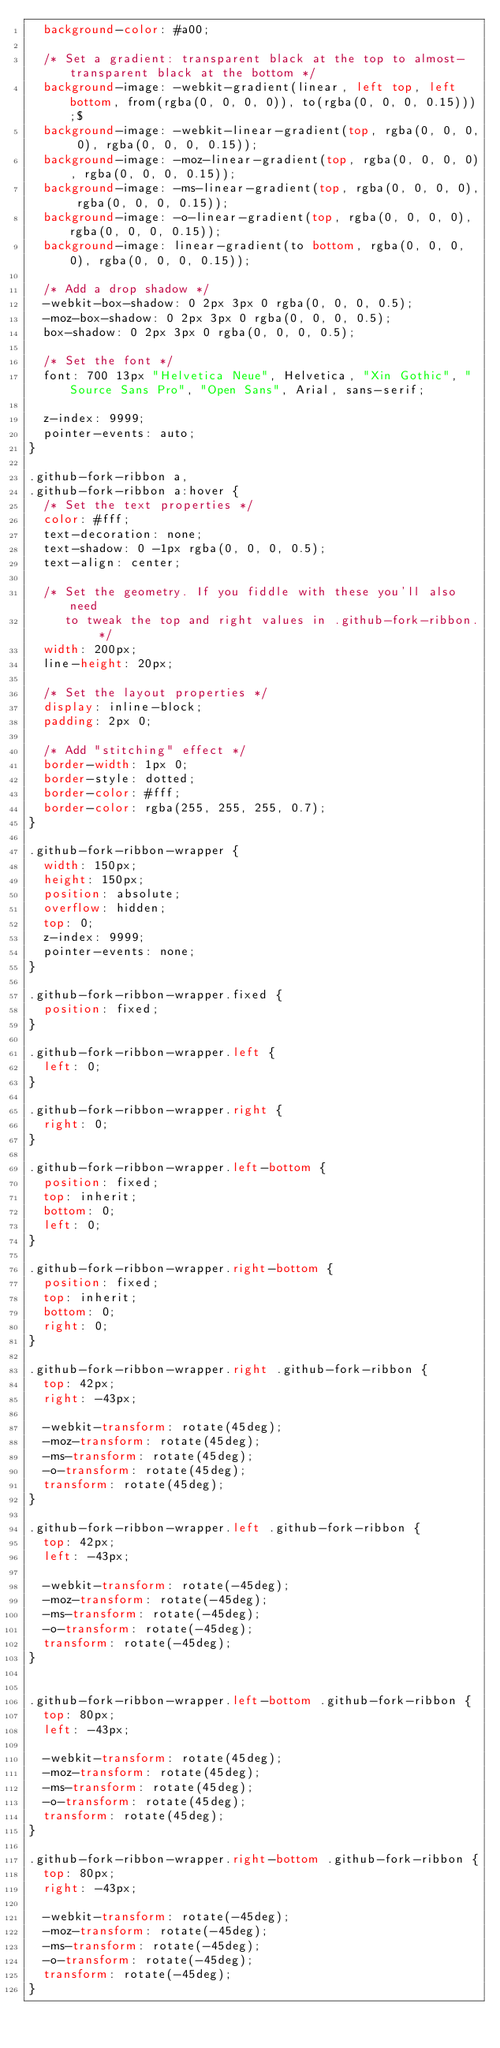<code> <loc_0><loc_0><loc_500><loc_500><_CSS_>  background-color: #a00;

  /* Set a gradient: transparent black at the top to almost-transparent black at the bottom */
  background-image: -webkit-gradient(linear, left top, left bottom, from(rgba(0, 0, 0, 0)), to(rgba(0, 0, 0, 0.15)));$
  background-image: -webkit-linear-gradient(top, rgba(0, 0, 0, 0), rgba(0, 0, 0, 0.15));
  background-image: -moz-linear-gradient(top, rgba(0, 0, 0, 0), rgba(0, 0, 0, 0.15));
  background-image: -ms-linear-gradient(top, rgba(0, 0, 0, 0), rgba(0, 0, 0, 0.15));
  background-image: -o-linear-gradient(top, rgba(0, 0, 0, 0), rgba(0, 0, 0, 0.15));
  background-image: linear-gradient(to bottom, rgba(0, 0, 0, 0), rgba(0, 0, 0, 0.15));

  /* Add a drop shadow */
  -webkit-box-shadow: 0 2px 3px 0 rgba(0, 0, 0, 0.5);
  -moz-box-shadow: 0 2px 3px 0 rgba(0, 0, 0, 0.5);
  box-shadow: 0 2px 3px 0 rgba(0, 0, 0, 0.5);

  /* Set the font */
  font: 700 13px "Helvetica Neue", Helvetica, "Xin Gothic", "Source Sans Pro", "Open Sans", Arial, sans-serif;

  z-index: 9999;
  pointer-events: auto;
}

.github-fork-ribbon a,
.github-fork-ribbon a:hover {
  /* Set the text properties */
  color: #fff;
  text-decoration: none;
  text-shadow: 0 -1px rgba(0, 0, 0, 0.5);
  text-align: center;

  /* Set the geometry. If you fiddle with these you'll also need
     to tweak the top and right values in .github-fork-ribbon. */
  width: 200px;
  line-height: 20px;

  /* Set the layout properties */
  display: inline-block;
  padding: 2px 0;

  /* Add "stitching" effect */
  border-width: 1px 0;
  border-style: dotted;
  border-color: #fff;
  border-color: rgba(255, 255, 255, 0.7);
}

.github-fork-ribbon-wrapper {
  width: 150px;
  height: 150px;
  position: absolute;
  overflow: hidden;
  top: 0;
  z-index: 9999;
  pointer-events: none;
}

.github-fork-ribbon-wrapper.fixed {
  position: fixed;
}

.github-fork-ribbon-wrapper.left {
  left: 0;
}

.github-fork-ribbon-wrapper.right {
  right: 0;
}

.github-fork-ribbon-wrapper.left-bottom {
  position: fixed;
  top: inherit;
  bottom: 0;
  left: 0;
}

.github-fork-ribbon-wrapper.right-bottom {
  position: fixed;
  top: inherit;
  bottom: 0;
  right: 0;
}

.github-fork-ribbon-wrapper.right .github-fork-ribbon {
  top: 42px;
  right: -43px;

  -webkit-transform: rotate(45deg);
  -moz-transform: rotate(45deg);
  -ms-transform: rotate(45deg);
  -o-transform: rotate(45deg);
  transform: rotate(45deg);
}

.github-fork-ribbon-wrapper.left .github-fork-ribbon {
  top: 42px;
  left: -43px;

  -webkit-transform: rotate(-45deg);
  -moz-transform: rotate(-45deg);
  -ms-transform: rotate(-45deg);
  -o-transform: rotate(-45deg);
  transform: rotate(-45deg);
}


.github-fork-ribbon-wrapper.left-bottom .github-fork-ribbon {
  top: 80px;
  left: -43px;

  -webkit-transform: rotate(45deg);
  -moz-transform: rotate(45deg);
  -ms-transform: rotate(45deg);
  -o-transform: rotate(45deg);
  transform: rotate(45deg);
}

.github-fork-ribbon-wrapper.right-bottom .github-fork-ribbon {
  top: 80px;
  right: -43px;

  -webkit-transform: rotate(-45deg);
  -moz-transform: rotate(-45deg);
  -ms-transform: rotate(-45deg);
  -o-transform: rotate(-45deg);
  transform: rotate(-45deg);
}</code> 